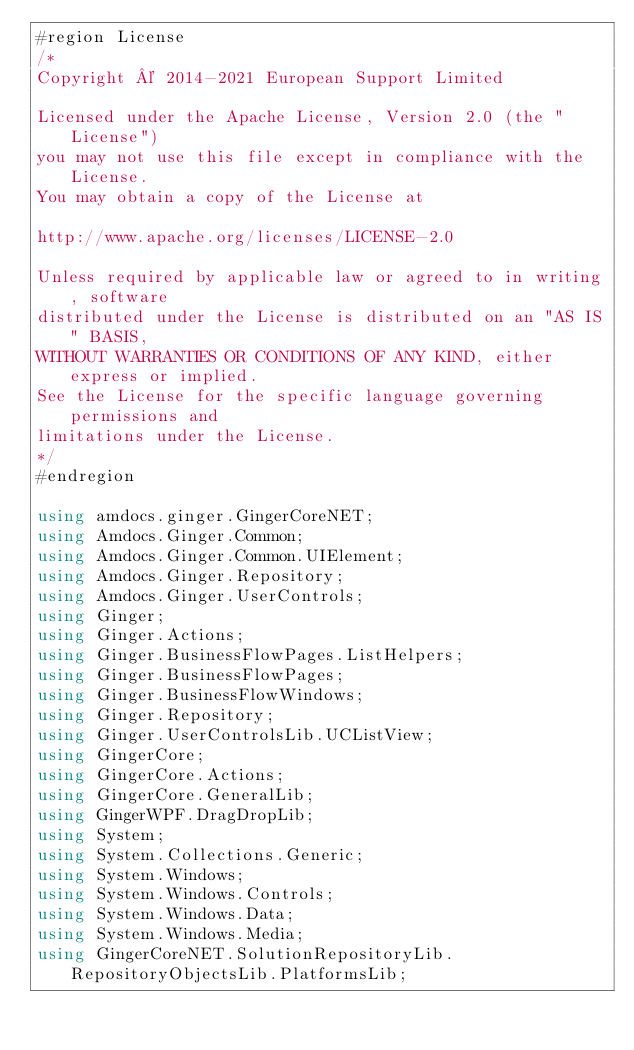Convert code to text. <code><loc_0><loc_0><loc_500><loc_500><_C#_>#region License
/*
Copyright © 2014-2021 European Support Limited

Licensed under the Apache License, Version 2.0 (the "License")
you may not use this file except in compliance with the License.
You may obtain a copy of the License at 

http://www.apache.org/licenses/LICENSE-2.0 

Unless required by applicable law or agreed to in writing, software
distributed under the License is distributed on an "AS IS" BASIS, 
WITHOUT WARRANTIES OR CONDITIONS OF ANY KIND, either express or implied. 
See the License for the specific language governing permissions and 
limitations under the License. 
*/
#endregion

using amdocs.ginger.GingerCoreNET;
using Amdocs.Ginger.Common;
using Amdocs.Ginger.Common.UIElement;
using Amdocs.Ginger.Repository;
using Amdocs.Ginger.UserControls;
using Ginger;
using Ginger.Actions;
using Ginger.BusinessFlowPages.ListHelpers;
using Ginger.BusinessFlowPages;
using Ginger.BusinessFlowWindows;
using Ginger.Repository;
using Ginger.UserControlsLib.UCListView;
using GingerCore;
using GingerCore.Actions;
using GingerCore.GeneralLib;
using GingerWPF.DragDropLib;
using System;
using System.Collections.Generic;
using System.Windows;
using System.Windows.Controls;
using System.Windows.Data;
using System.Windows.Media;
using GingerCoreNET.SolutionRepositoryLib.RepositoryObjectsLib.PlatformsLib;</code> 